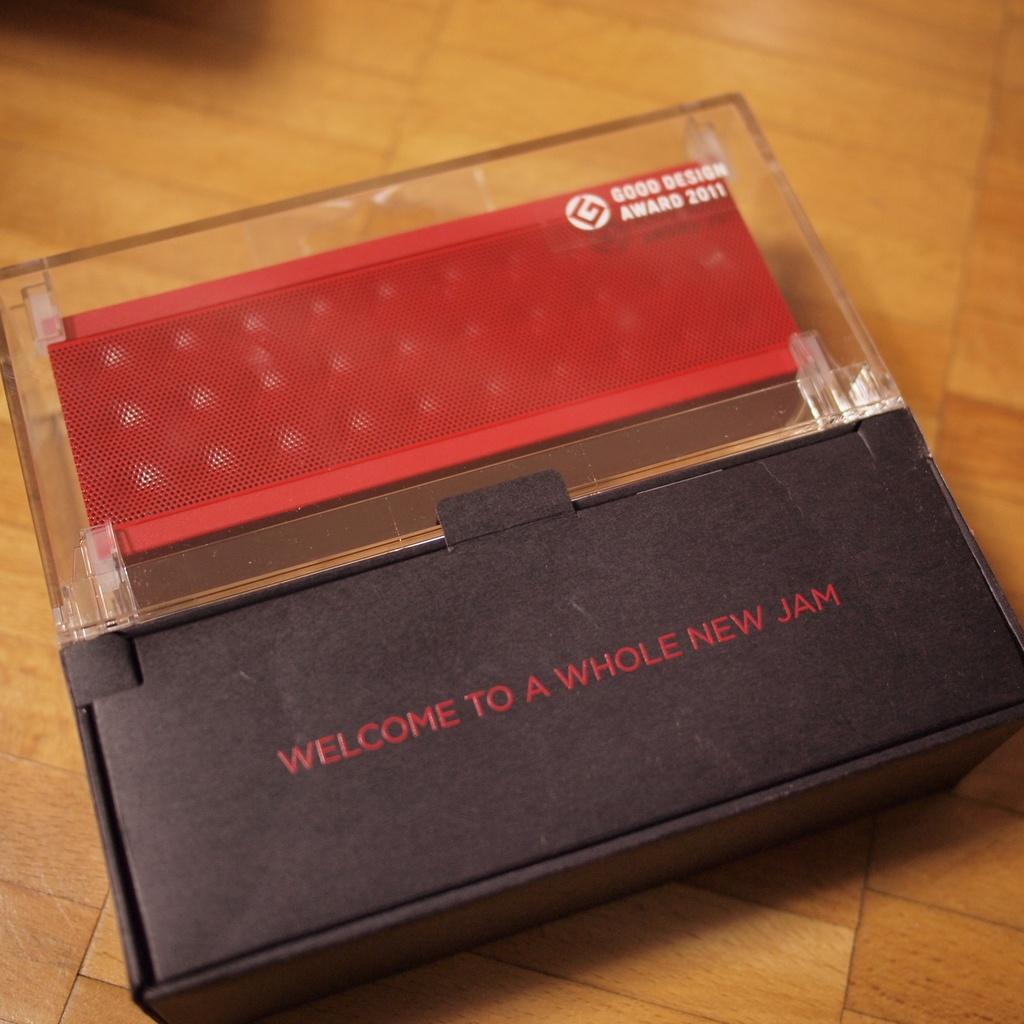Welcome to a new what?
Make the answer very short. Jam. 